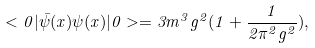<formula> <loc_0><loc_0><loc_500><loc_500>< 0 | \bar { \psi } ( x ) \psi ( x ) | 0 > = 3 m ^ { 3 } g ^ { 2 } ( 1 + { \frac { 1 } { 2 \pi ^ { 2 } g ^ { 2 } } } ) ,</formula> 